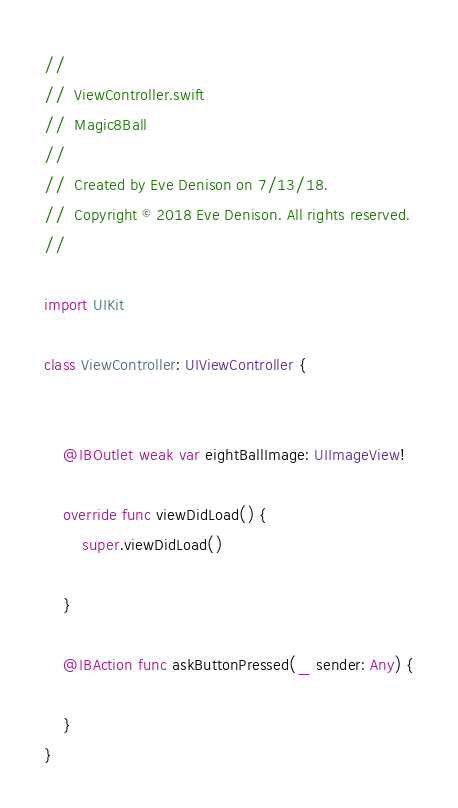<code> <loc_0><loc_0><loc_500><loc_500><_Swift_>//
//  ViewController.swift
//  Magic8Ball
//
//  Created by Eve Denison on 7/13/18.
//  Copyright © 2018 Eve Denison. All rights reserved.
//

import UIKit

class ViewController: UIViewController {
    

    @IBOutlet weak var eightBallImage: UIImageView!
    
    override func viewDidLoad() {
        super.viewDidLoad()
        
    }
    
    @IBAction func askButtonPressed(_ sender: Any) {
        
    }
}

</code> 